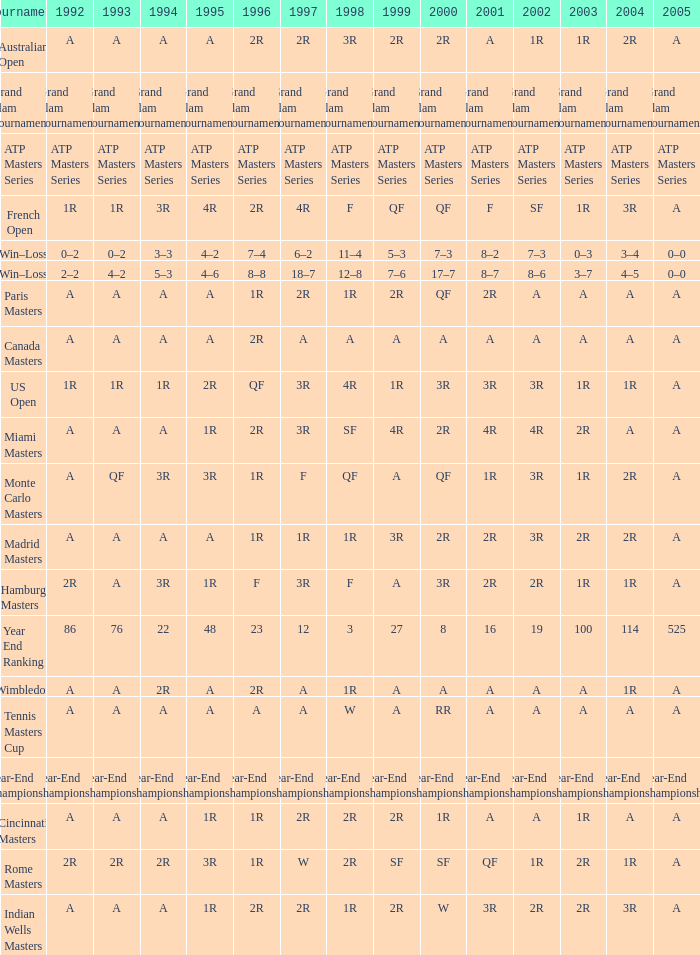What is 2005, when 1998 is "F", and when 2002 is "2R"? A. 